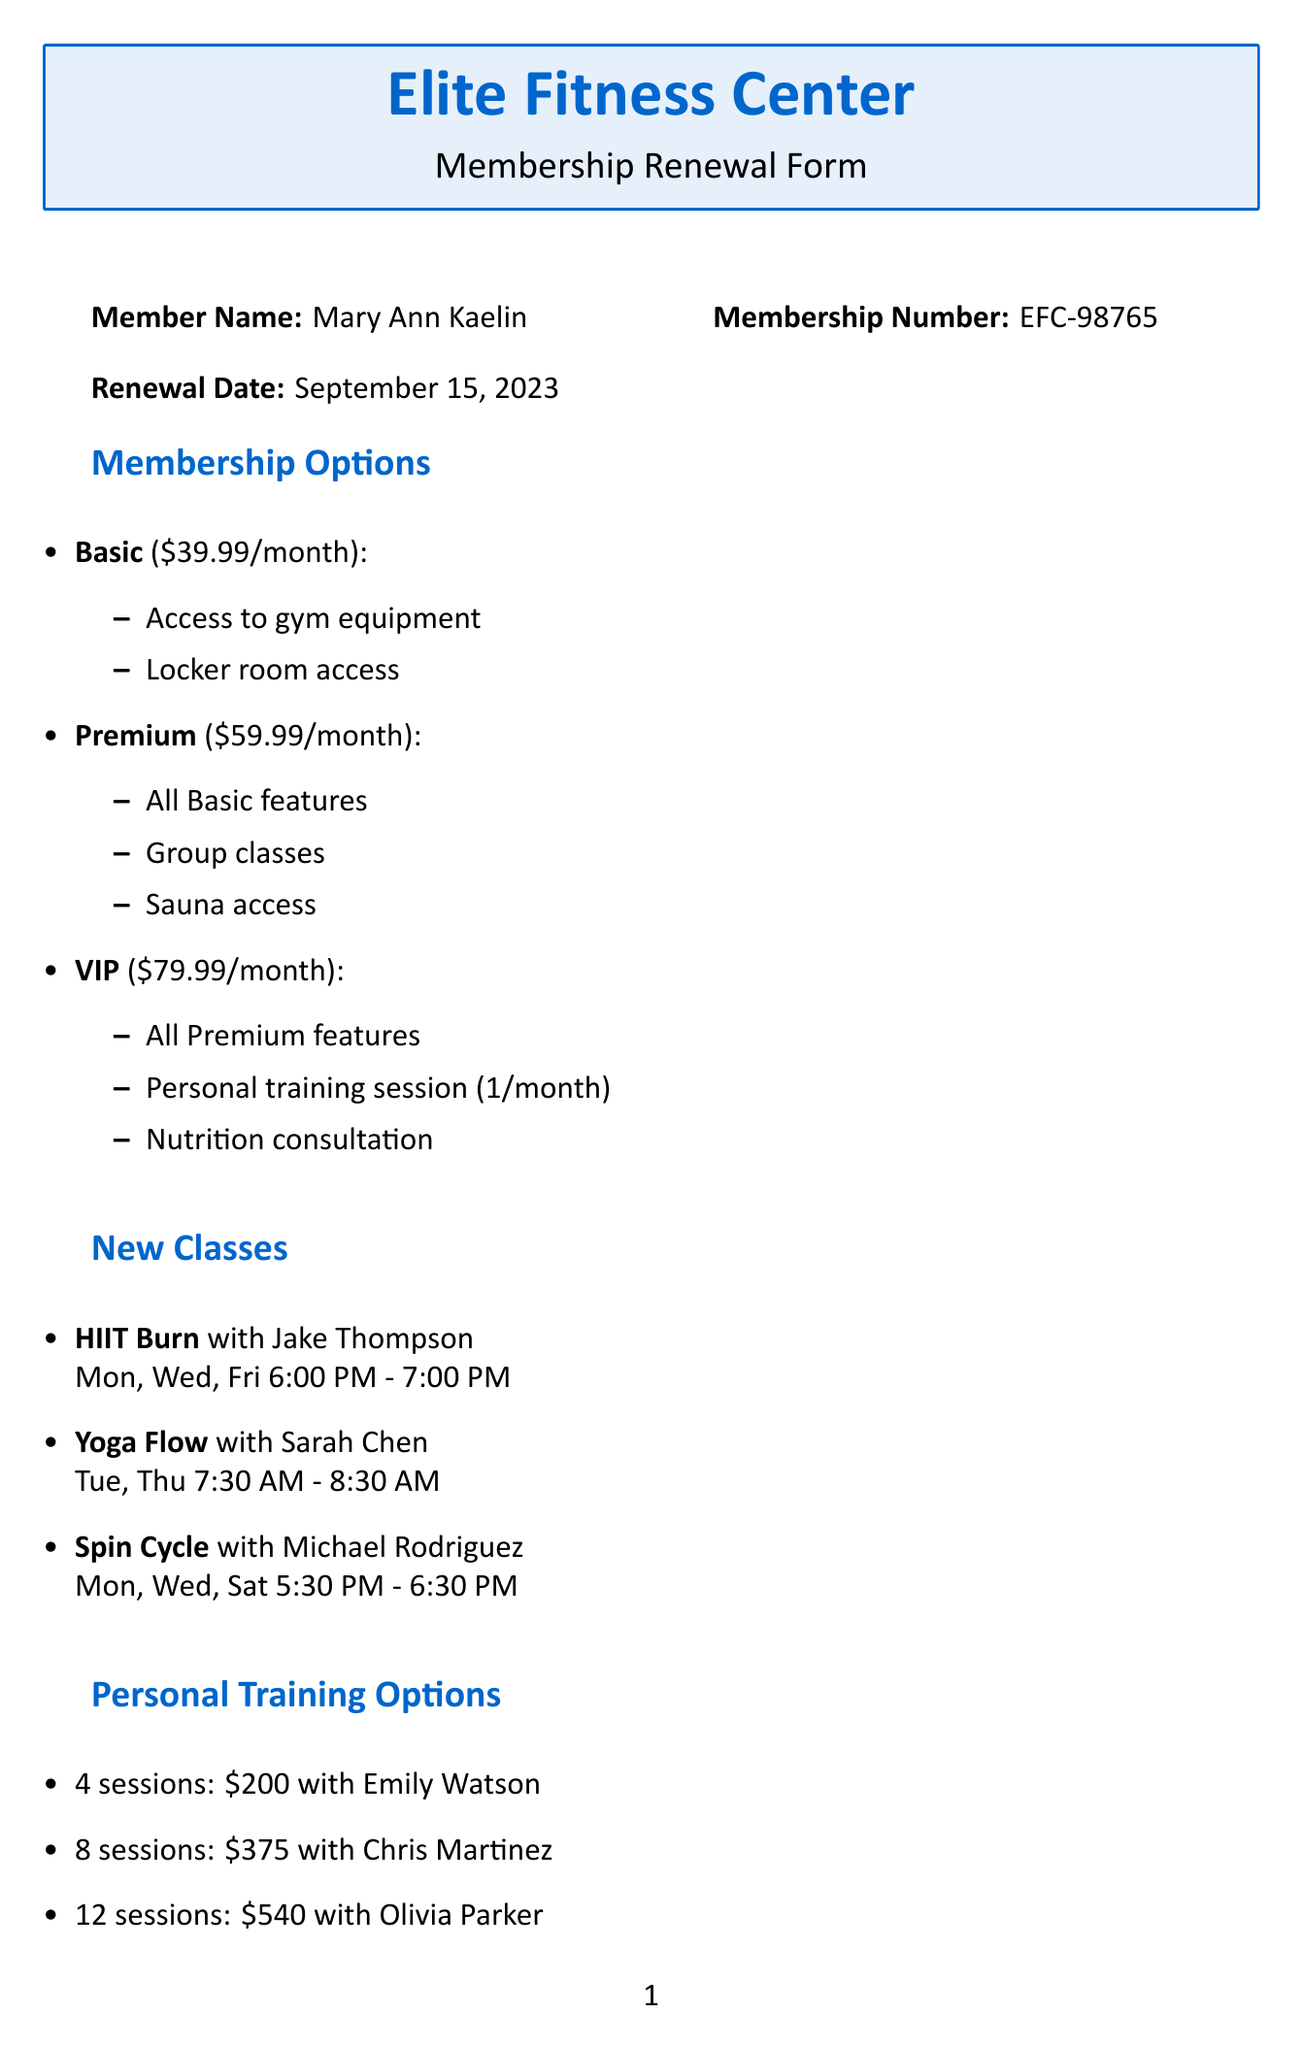What is the membership number? The membership number is indicated in the document as EFC-98765.
Answer: EFC-98765 Who is the instructor for Yoga Flow? The instructor's name for Yoga Flow class is mentioned as Sarah Chen.
Answer: Sarah Chen What is the price of the Premium membership? The document states that the Premium membership is priced at $59.99/month.
Answer: $59.99/month How many sessions does Olivia Parker offer? According to the personal training options, Olivia Parker offers 12 sessions.
Answer: 12 What is the special offer for upgrading to VIP membership? The document describes a special offer that includes a free fitness assessment and personalized workout plan when upgrading to VIP membership.
Answer: Free fitness assessment and personalized workout plan What is the renewal date for Mary Ann's membership? The renewal date is clearly specified in the document as September 15, 2023.
Answer: September 15, 2023 How many different membership options are listed? The document lists three different membership options: Basic, Premium, and VIP.
Answer: Three What is the referral bonus for referring a friend? The document specifies that referring a friend will grant a free month of membership.
Answer: Free month of membership What payment methods are accepted? The document lists the accepted payment methods as Credit Card, Debit Card, Bank Transfer, and PayPal.
Answer: Credit Card, Debit Card, Bank Transfer, PayPal 